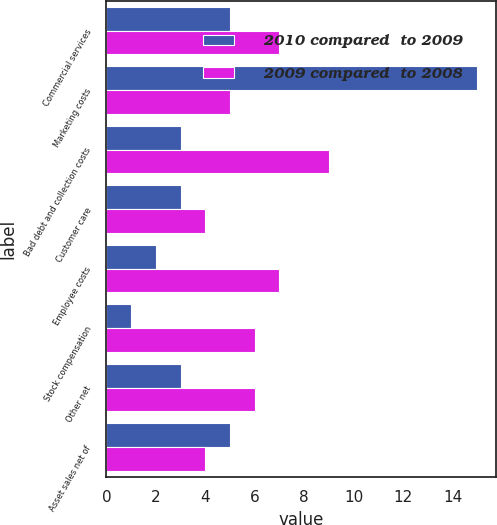<chart> <loc_0><loc_0><loc_500><loc_500><stacked_bar_chart><ecel><fcel>Commercial services<fcel>Marketing costs<fcel>Bad debt and collection costs<fcel>Customer care<fcel>Employee costs<fcel>Stock compensation<fcel>Other net<fcel>Asset sales net of<nl><fcel>2010 compared  to 2009<fcel>5<fcel>15<fcel>3<fcel>3<fcel>2<fcel>1<fcel>3<fcel>5<nl><fcel>2009 compared  to 2008<fcel>7<fcel>5<fcel>9<fcel>4<fcel>7<fcel>6<fcel>6<fcel>4<nl></chart> 